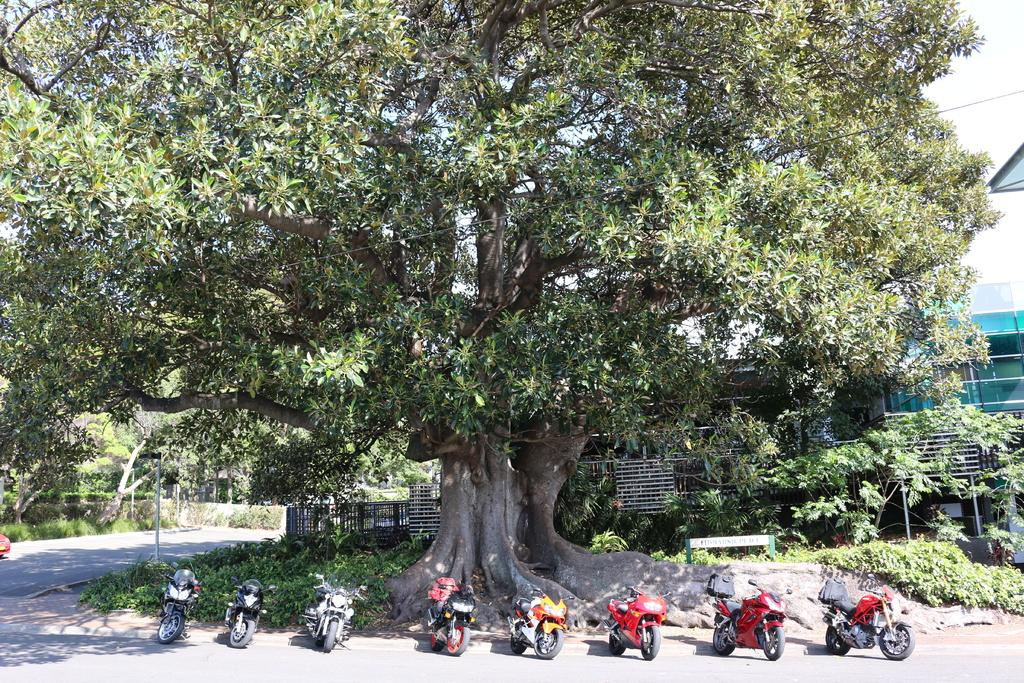What is the main subject in the center of the image? There are bikes in the center of the image. What can be seen in the background of the image? The sky, clouds, trees, fences, at least one building, a bench, grass, and plants are visible in the background of the image. What type of surface is present on the ground in the background? There is a road in the background of the image. Where is the clock located in the image? There is no clock present in the image. What type of coat is the servant wearing in the image? There is no servant present in the image. 